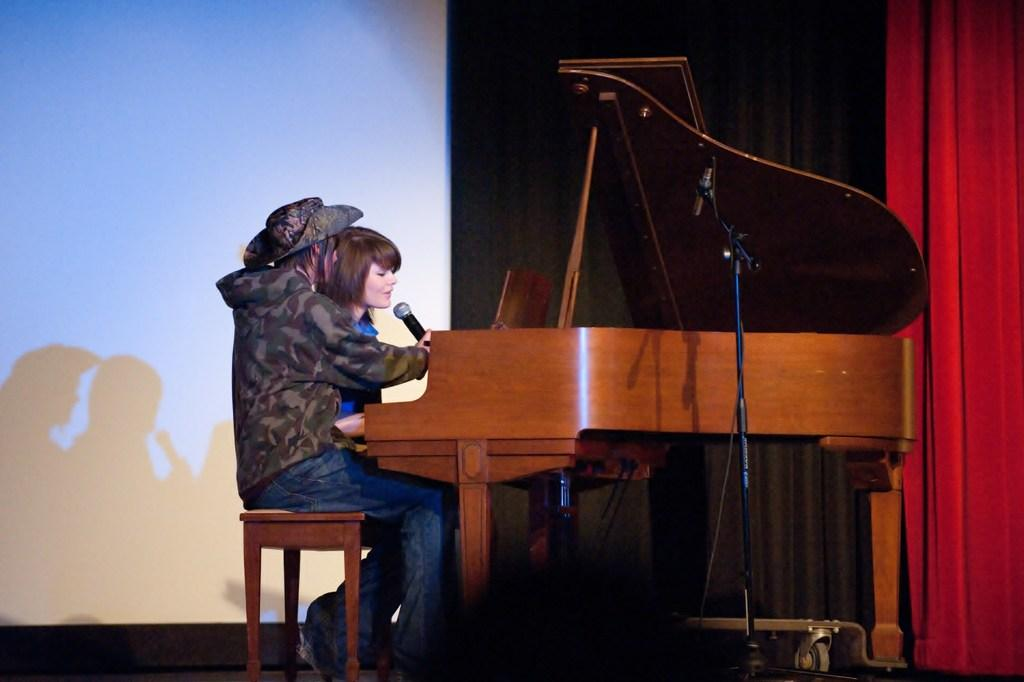Who is the main subject in the image? There is a woman in the image. What is the woman wearing? The woman is wearing a blue dress. What is the woman doing in the image? The woman is playing the piano and singing. What object is in front of the woman? There is a microphone in front of the woman. Who is beside the woman? There is a person beside the woman. What is the person beside the woman doing? The person beside the woman is holding a microphone. How many letters are visible on the cow in the image? There is no cow present in the image, so it is not possible to determine how many letters might be visible on it. 